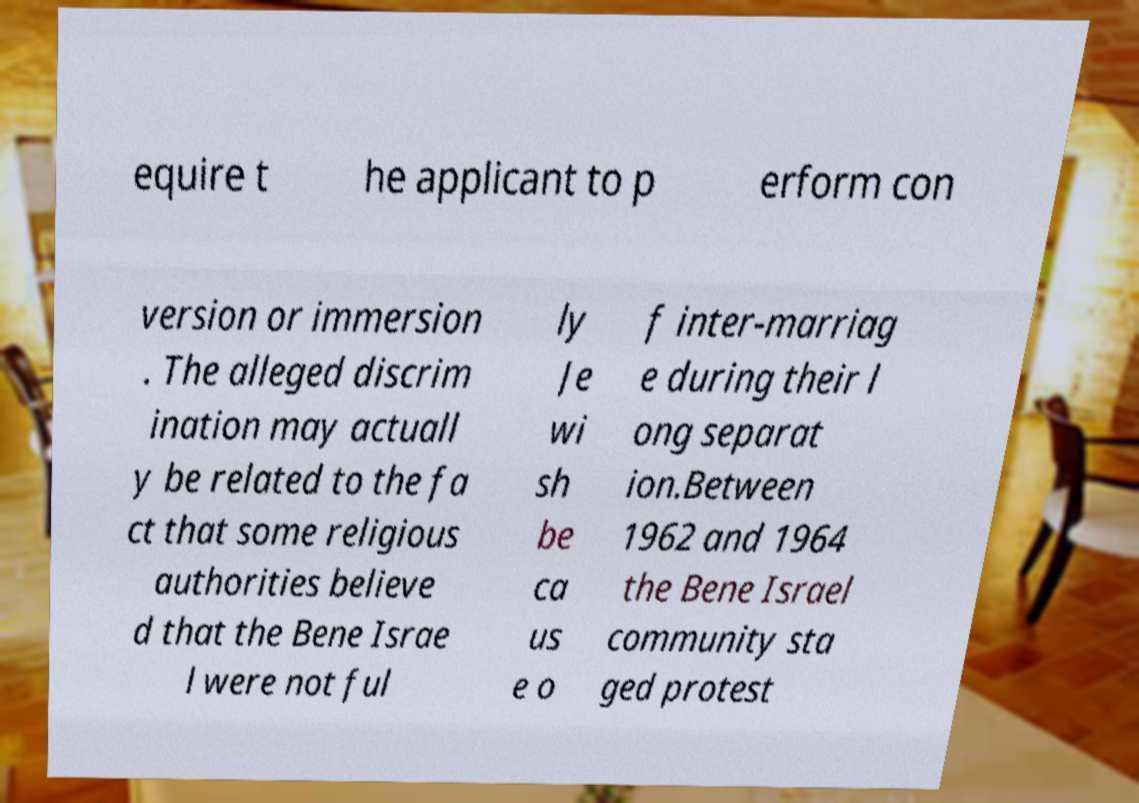For documentation purposes, I need the text within this image transcribed. Could you provide that? equire t he applicant to p erform con version or immersion . The alleged discrim ination may actuall y be related to the fa ct that some religious authorities believe d that the Bene Israe l were not ful ly Je wi sh be ca us e o f inter-marriag e during their l ong separat ion.Between 1962 and 1964 the Bene Israel community sta ged protest 